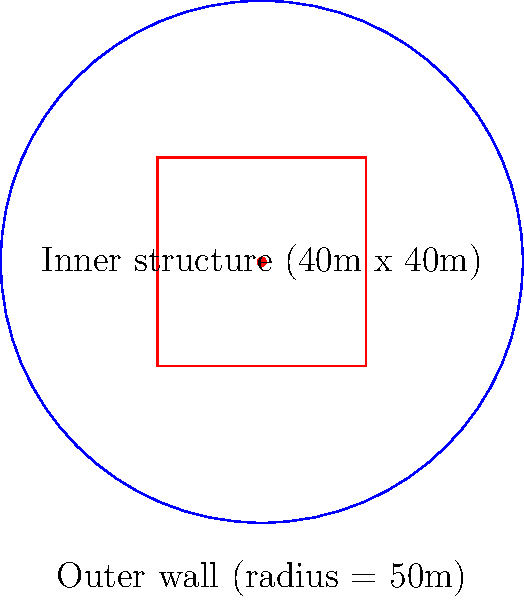An ancient fortified city has circular outer walls with a radius of 50 meters. Within the city, there is a rectangular inner structure measuring 40 meters by 40 meters. Calculate the area of the city that is not occupied by the inner structure. How might this spatial organization reflect the cultural priorities and defensive strategies of the ancient civilization? To solve this problem, we need to follow these steps:

1. Calculate the total area of the circular city:
   $A_{circle} = \pi r^2 = \pi (50\text{m})^2 = 7,853.98\text{m}^2$

2. Calculate the area of the rectangular inner structure:
   $A_{rectangle} = l \times w = 40\text{m} \times 40\text{m} = 1,600\text{m}^2$

3. Subtract the area of the inner structure from the total area:
   $A_{unoccupied} = A_{circle} - A_{rectangle} = 7,853.98\text{m}^2 - 1,600\text{m}^2 = 6,253.98\text{m}^2$

The spatial organization reflects cultural priorities and defensive strategies:

- Circular outer walls provide maximum internal space with minimum perimeter, optimizing defense.
- The central rectangular structure could represent administrative, religious, or military importance, highlighting the civilization's power structure.
- The significant unoccupied area suggests space for residential zones, markets, and potential military maneuvers, indicating a balance between civilian life and defensive needs.
Answer: $6,253.98\text{m}^2$ 